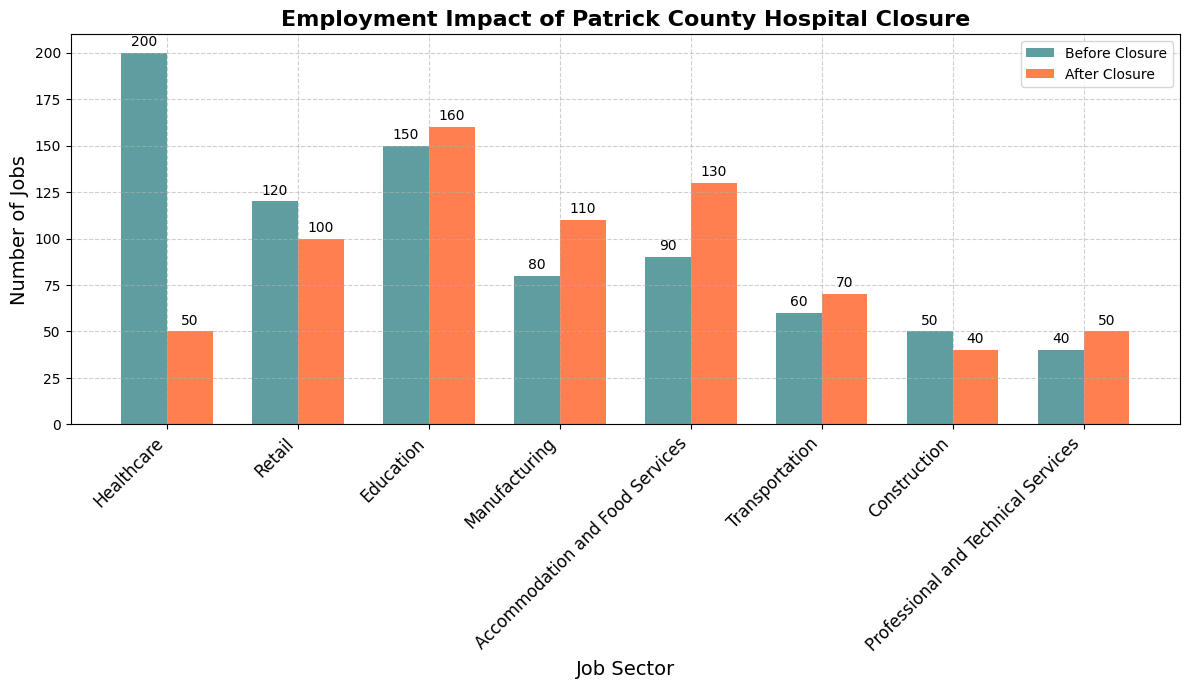Which job sector experienced the largest decline in the number of jobs after the closure of Patrick County Hospital? By looking at the difference in job numbers before and after the closure, Healthcare saw the largest decline from 200 to 50, a decrease of 150 jobs.
Answer: Healthcare Did the number of jobs in the Retail sector increase or decrease after the hospital closure? Comparing the values, the Retail sector had 120 jobs before and 100 jobs after, indicating a decrease.
Answer: Decrease What is the sum of jobs in the Education and Manufacturing sectors after the closure? Adding the 'After Closure' values for Education (160) and Manufacturing (110), the sum is 270.
Answer: 270 Which sector had the least change in job numbers after the closure? By comparing the difference for each sector, Transportation changed the least from 60 to 70, a difference of 10 jobs.
Answer: Transportation What is the total number of jobs across all sectors before the closure? Summing up the 'Before Closure' values: Healthcare (200) + Retail (120) + Education (150) + Manufacturing (80) + Accommodation and Food Services (90) + Transportation (60) + Construction (50) + Professional and Technical Services (40), the total is 790.
Answer: 790 How many more jobs are there in the Healthcare sector before the closure compared to after the closure? Subtracting the 'After Closure' value from the 'Before Closure' value for Healthcare: 200 - 50 = 150.
Answer: 150 Which job sector saw an increase in job numbers after the closure and has the highest final count? Comparing the 'After Closure' values of sectors with increases: Education (160), Manufacturing (110), Accommodation and Food Services (130), Transportation (70), Professional and Technical Services (50), Education has the highest with 160 jobs.
Answer: Education Did any sector have the same number of jobs before and after the closure? By reviewing each sector’s 'Before Closure' and 'After Closure' values, none of the sectors had the same number of jobs.
Answer: No What is the difference in the number of jobs in the Accommodation and Food Services sector before and after the closure? Subtracting the 'Before Closure' value from the 'After Closure' value for Accommodation and Food Services: 130 - 90 = 40.
Answer: 40 By what percentage did the number of jobs in the Healthcare sector decrease after the closure? The percentage decrease is calculated as ((200 - 50) / 200) * 100 = 75%.
Answer: 75% 